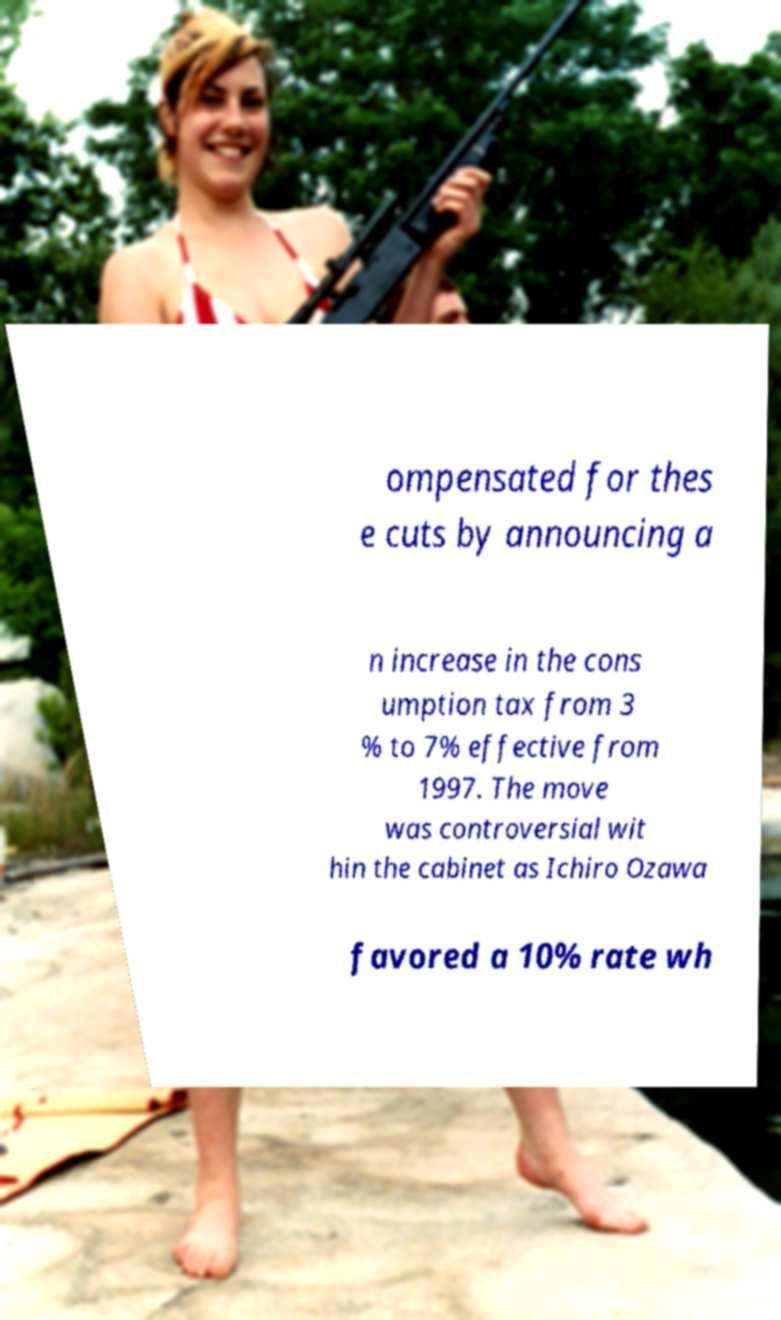Can you read and provide the text displayed in the image?This photo seems to have some interesting text. Can you extract and type it out for me? ompensated for thes e cuts by announcing a n increase in the cons umption tax from 3 % to 7% effective from 1997. The move was controversial wit hin the cabinet as Ichiro Ozawa favored a 10% rate wh 